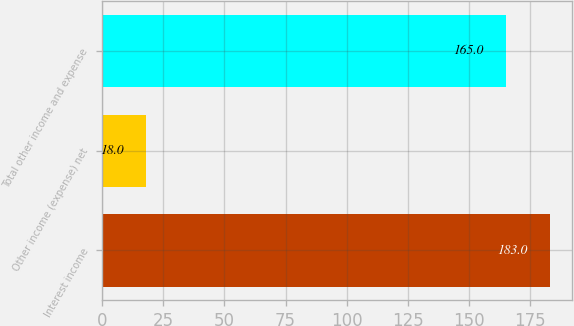Convert chart. <chart><loc_0><loc_0><loc_500><loc_500><bar_chart><fcel>Interest income<fcel>Other income (expense) net<fcel>Total other income and expense<nl><fcel>183<fcel>18<fcel>165<nl></chart> 